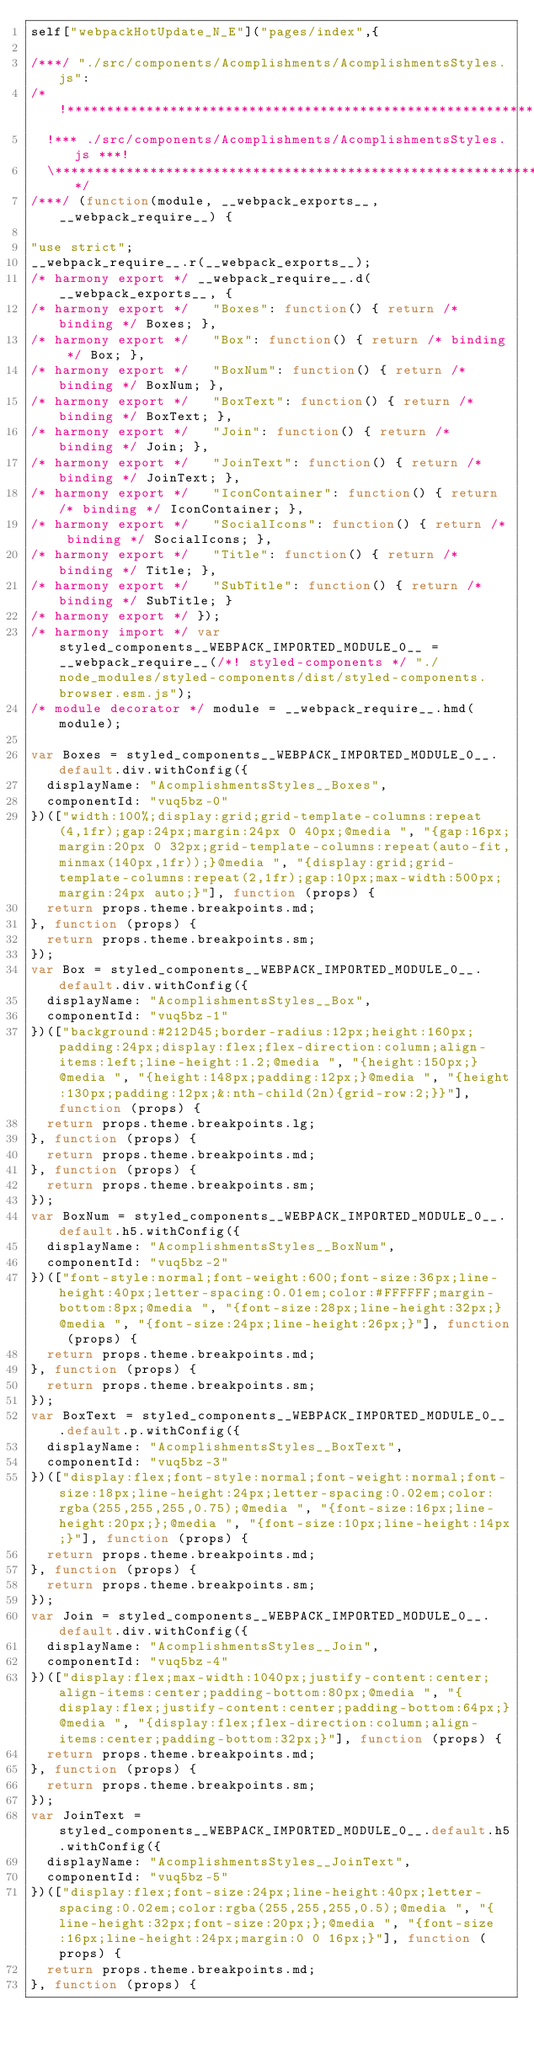Convert code to text. <code><loc_0><loc_0><loc_500><loc_500><_JavaScript_>self["webpackHotUpdate_N_E"]("pages/index",{

/***/ "./src/components/Acomplishments/AcomplishmentsStyles.js":
/*!***************************************************************!*\
  !*** ./src/components/Acomplishments/AcomplishmentsStyles.js ***!
  \***************************************************************/
/***/ (function(module, __webpack_exports__, __webpack_require__) {

"use strict";
__webpack_require__.r(__webpack_exports__);
/* harmony export */ __webpack_require__.d(__webpack_exports__, {
/* harmony export */   "Boxes": function() { return /* binding */ Boxes; },
/* harmony export */   "Box": function() { return /* binding */ Box; },
/* harmony export */   "BoxNum": function() { return /* binding */ BoxNum; },
/* harmony export */   "BoxText": function() { return /* binding */ BoxText; },
/* harmony export */   "Join": function() { return /* binding */ Join; },
/* harmony export */   "JoinText": function() { return /* binding */ JoinText; },
/* harmony export */   "IconContainer": function() { return /* binding */ IconContainer; },
/* harmony export */   "SocialIcons": function() { return /* binding */ SocialIcons; },
/* harmony export */   "Title": function() { return /* binding */ Title; },
/* harmony export */   "SubTitle": function() { return /* binding */ SubTitle; }
/* harmony export */ });
/* harmony import */ var styled_components__WEBPACK_IMPORTED_MODULE_0__ = __webpack_require__(/*! styled-components */ "./node_modules/styled-components/dist/styled-components.browser.esm.js");
/* module decorator */ module = __webpack_require__.hmd(module);

var Boxes = styled_components__WEBPACK_IMPORTED_MODULE_0__.default.div.withConfig({
  displayName: "AcomplishmentsStyles__Boxes",
  componentId: "vuq5bz-0"
})(["width:100%;display:grid;grid-template-columns:repeat(4,1fr);gap:24px;margin:24px 0 40px;@media ", "{gap:16px;margin:20px 0 32px;grid-template-columns:repeat(auto-fit,minmax(140px,1fr));}@media ", "{display:grid;grid-template-columns:repeat(2,1fr);gap:10px;max-width:500px;margin:24px auto;}"], function (props) {
  return props.theme.breakpoints.md;
}, function (props) {
  return props.theme.breakpoints.sm;
});
var Box = styled_components__WEBPACK_IMPORTED_MODULE_0__.default.div.withConfig({
  displayName: "AcomplishmentsStyles__Box",
  componentId: "vuq5bz-1"
})(["background:#212D45;border-radius:12px;height:160px;padding:24px;display:flex;flex-direction:column;align-items:left;line-height:1.2;@media ", "{height:150px;}@media ", "{height:148px;padding:12px;}@media ", "{height:130px;padding:12px;&:nth-child(2n){grid-row:2;}}"], function (props) {
  return props.theme.breakpoints.lg;
}, function (props) {
  return props.theme.breakpoints.md;
}, function (props) {
  return props.theme.breakpoints.sm;
});
var BoxNum = styled_components__WEBPACK_IMPORTED_MODULE_0__.default.h5.withConfig({
  displayName: "AcomplishmentsStyles__BoxNum",
  componentId: "vuq5bz-2"
})(["font-style:normal;font-weight:600;font-size:36px;line-height:40px;letter-spacing:0.01em;color:#FFFFFF;margin-bottom:8px;@media ", "{font-size:28px;line-height:32px;}@media ", "{font-size:24px;line-height:26px;}"], function (props) {
  return props.theme.breakpoints.md;
}, function (props) {
  return props.theme.breakpoints.sm;
});
var BoxText = styled_components__WEBPACK_IMPORTED_MODULE_0__.default.p.withConfig({
  displayName: "AcomplishmentsStyles__BoxText",
  componentId: "vuq5bz-3"
})(["display:flex;font-style:normal;font-weight:normal;font-size:18px;line-height:24px;letter-spacing:0.02em;color:rgba(255,255,255,0.75);@media ", "{font-size:16px;line-height:20px;};@media ", "{font-size:10px;line-height:14px;}"], function (props) {
  return props.theme.breakpoints.md;
}, function (props) {
  return props.theme.breakpoints.sm;
});
var Join = styled_components__WEBPACK_IMPORTED_MODULE_0__.default.div.withConfig({
  displayName: "AcomplishmentsStyles__Join",
  componentId: "vuq5bz-4"
})(["display:flex;max-width:1040px;justify-content:center;align-items:center;padding-bottom:80px;@media ", "{display:flex;justify-content:center;padding-bottom:64px;}@media ", "{display:flex;flex-direction:column;align-items:center;padding-bottom:32px;}"], function (props) {
  return props.theme.breakpoints.md;
}, function (props) {
  return props.theme.breakpoints.sm;
});
var JoinText = styled_components__WEBPACK_IMPORTED_MODULE_0__.default.h5.withConfig({
  displayName: "AcomplishmentsStyles__JoinText",
  componentId: "vuq5bz-5"
})(["display:flex;font-size:24px;line-height:40px;letter-spacing:0.02em;color:rgba(255,255,255,0.5);@media ", "{line-height:32px;font-size:20px;};@media ", "{font-size:16px;line-height:24px;margin:0 0 16px;}"], function (props) {
  return props.theme.breakpoints.md;
}, function (props) {</code> 